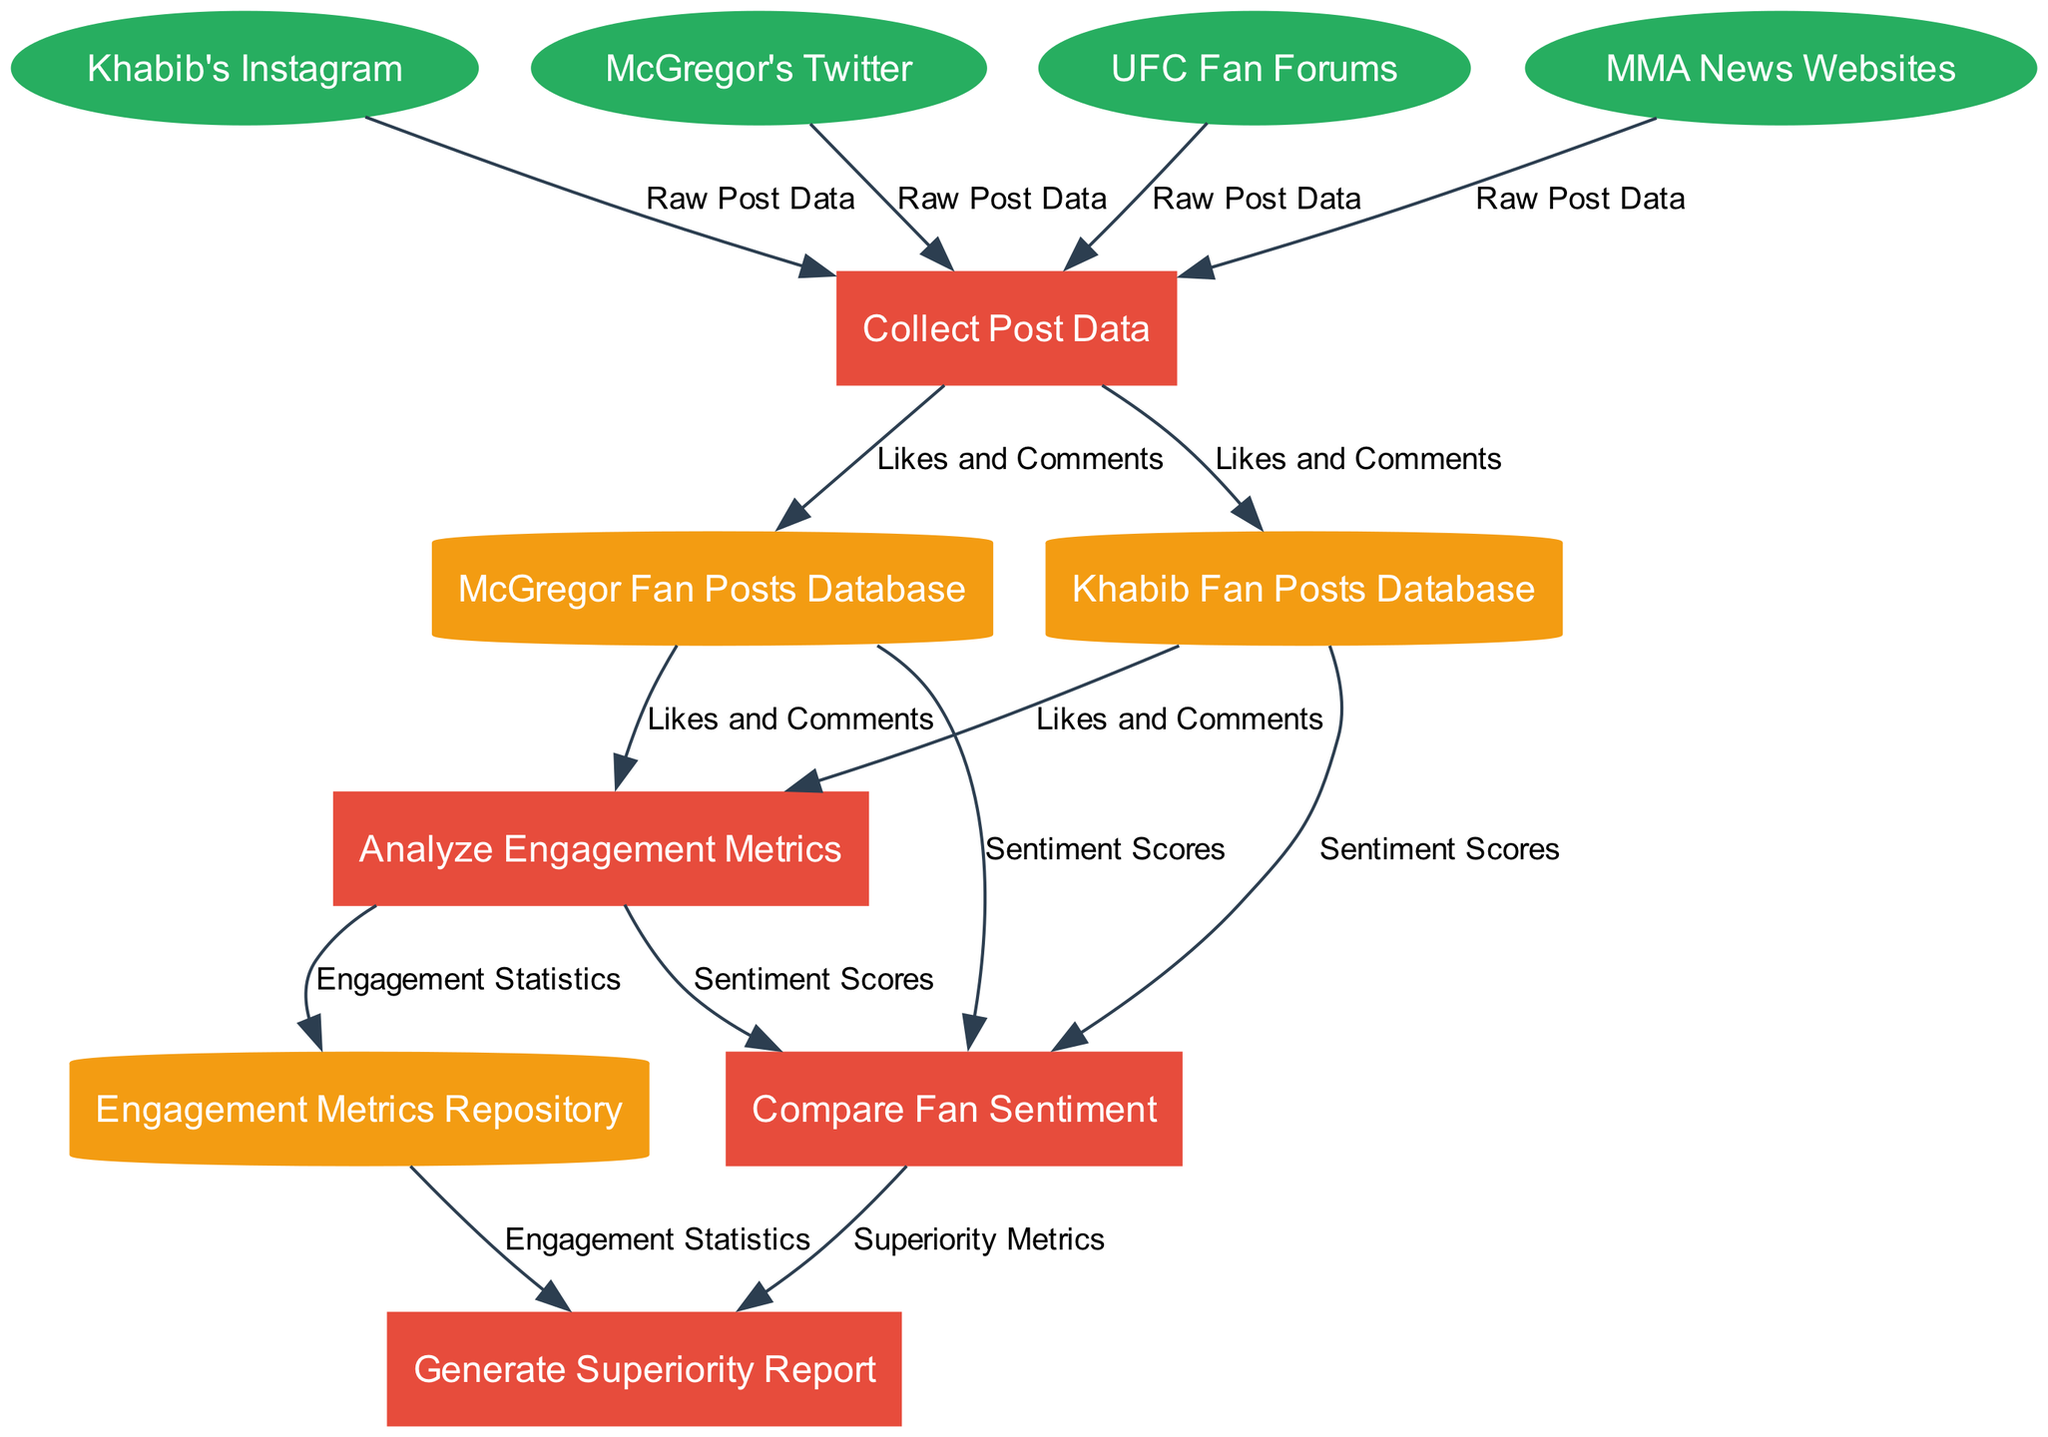What are the external entities involved in the analysis? The external entities in the diagram are listed clearly, including Khabib's Instagram, McGregor's Twitter, UFC Fan Forums, and MMA News Websites.
Answer: Khabib's Instagram, McGregor's Twitter, UFC Fan Forums, MMA News Websites How many processes are represented in the diagram? The diagram includes four distinct processes: Collect Post Data, Analyze Engagement Metrics, Compare Fan Sentiment, and Generate Superiority Report. Counting these processes gives a total of four.
Answer: 4 Which data store is used to collect engagement metrics? The Engagement Metrics Repository is specifically mentioned as the data store that holds the engagement metrics. It is linked directly to the processes analyzing these metrics.
Answer: Engagement Metrics Repository What type of data is flowing from Khabib's Instagram to the first process? The Raw Post Data is the specific type of data that flows from Khabib's Instagram to the first process, which is Collect Post Data.
Answer: Raw Post Data Which process generates the Superiority Report? The Generate Superiority Report process is the one that produces the Superiority Report based on the previous analyses conducted in the diagram.
Answer: Generate Superiority Report How do the process Compare Fan Sentiment and Analyze Engagement Metrics interact? The Compare Fan Sentiment process relies on the output from the Analyze Engagement Metrics process, indicating that it receives data flows related to sentiment scores and therefore ensures interaction between these two processes.
Answer: By data flow How many edges connect the data stores to the processes in the diagram? There are multiple connections between data stores and processes. Specifically, there are five edges, showing interactions between each process and the data stores related to the posts and engagement metrics.
Answer: 5 Which external entity provides data specifically for Khabib's fan posts? Khabib's Instagram is the external entity that provides data for Khabib's fan posts, indicated by its direct connection to the Collect Post Data process.
Answer: Khabib's Instagram What do Sentiment Scores represent in the context of this diagram? Sentiment Scores represent the outcome of the process that compares fan sentiment, which analyzes data from fan posts about Khabib and McGregor to provide a score reflecting fan reactions.
Answer: Fan reactions score 